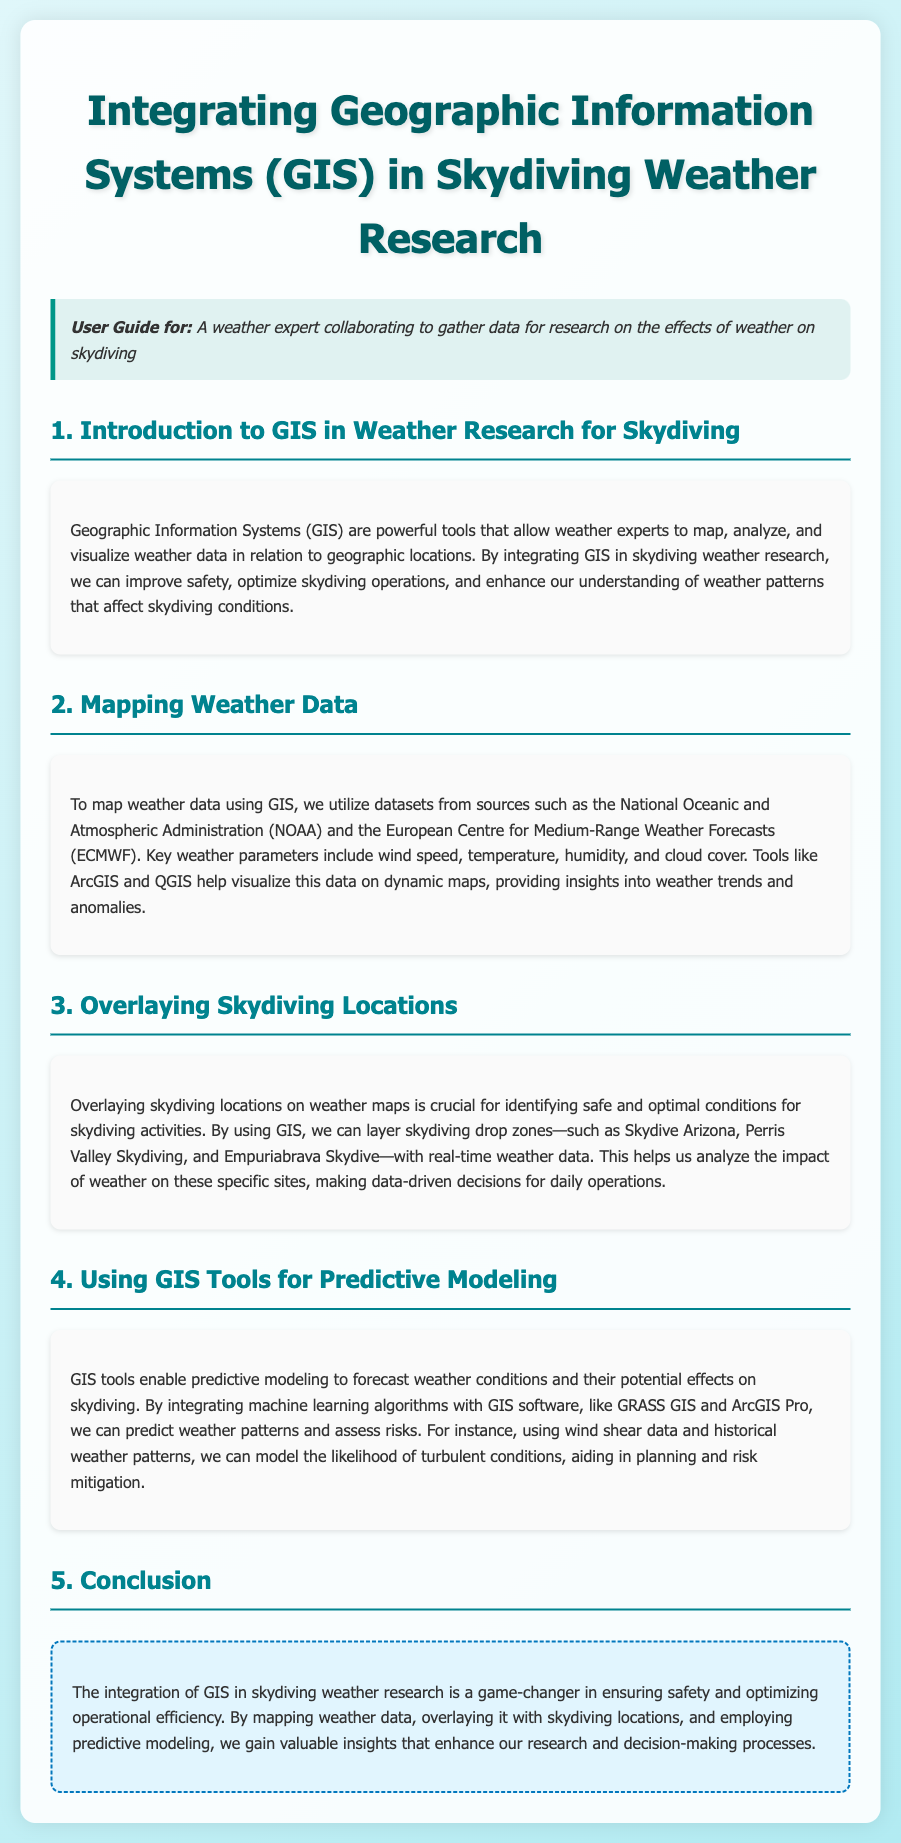What is the main focus of integrating GIS in skydiving research? The main focus is to improve safety, optimize skydiving operations, and enhance understanding of weather patterns that affect skydiving conditions.
Answer: Improve safety, optimize skydiving operations, enhance understanding of weather patterns Which organizations provide datasets for mapping weather data? The organizations mentioned are the National Oceanic and Atmospheric Administration (NOAA) and the European Centre for Medium-Range Weather Forecasts (ECMWF).
Answer: NOAA, ECMWF What are key weather parameters used in GIS for skydiving? Key weather parameters include wind speed, temperature, humidity, and cloud cover.
Answer: Wind speed, temperature, humidity, cloud cover What is the purpose of overlaying skydiving locations on weather maps? The purpose is to identify safe and optimal conditions for skydiving activities.
Answer: Identify safe and optimal conditions Which GIS tools are mentioned for predictive modeling? The GIS tools mentioned for predictive modeling are GRASS GIS and ArcGIS Pro.
Answer: GRASS GIS, ArcGIS Pro How do GIS tools aid in risk mitigation for skydiving? GIS tools aid in risk mitigation by predicting weather patterns and assessing risks related to skydiving conditions.
Answer: Predicting weather patterns, assessing risks What is the benefit of using machine learning algorithms with GIS software in this research? The benefit is to predict weather patterns and assess risks for skydiving.
Answer: Predict weather patterns, assess risks What crucial feature helps analyze the impact of weather on specific skydiving sites? The crucial feature is real-time weather data overlaying skydiving drop zones.
Answer: Real-time weather data overlaying skydiving drop zones 